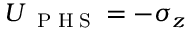Convert formula to latex. <formula><loc_0><loc_0><loc_500><loc_500>U _ { P H S } = - \sigma _ { z }</formula> 